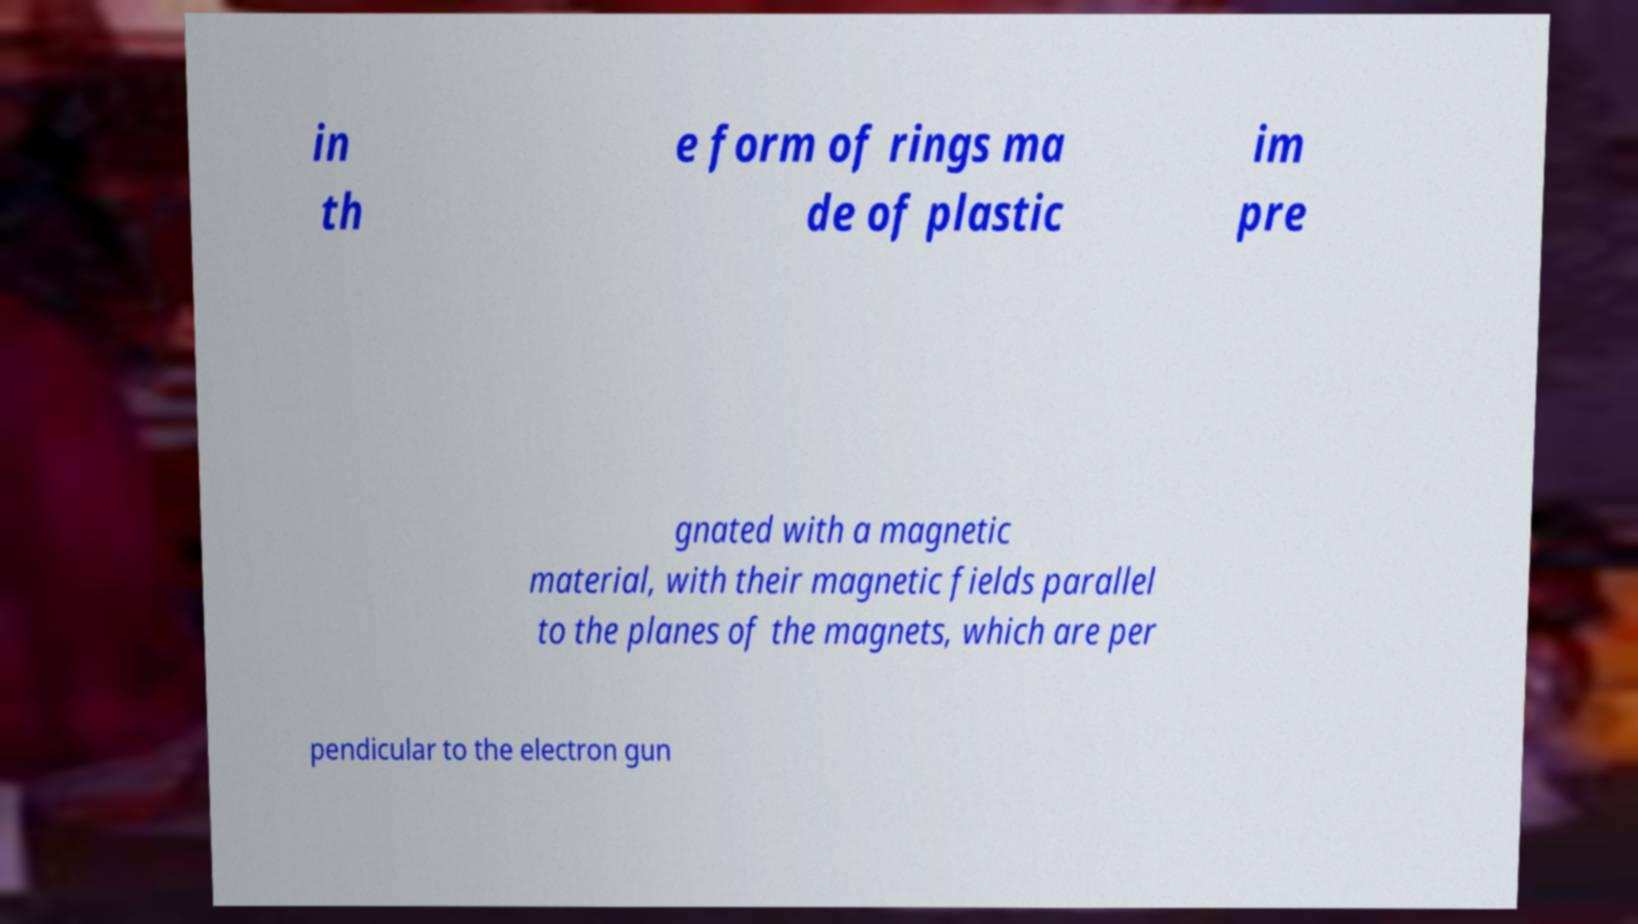For documentation purposes, I need the text within this image transcribed. Could you provide that? in th e form of rings ma de of plastic im pre gnated with a magnetic material, with their magnetic fields parallel to the planes of the magnets, which are per pendicular to the electron gun 